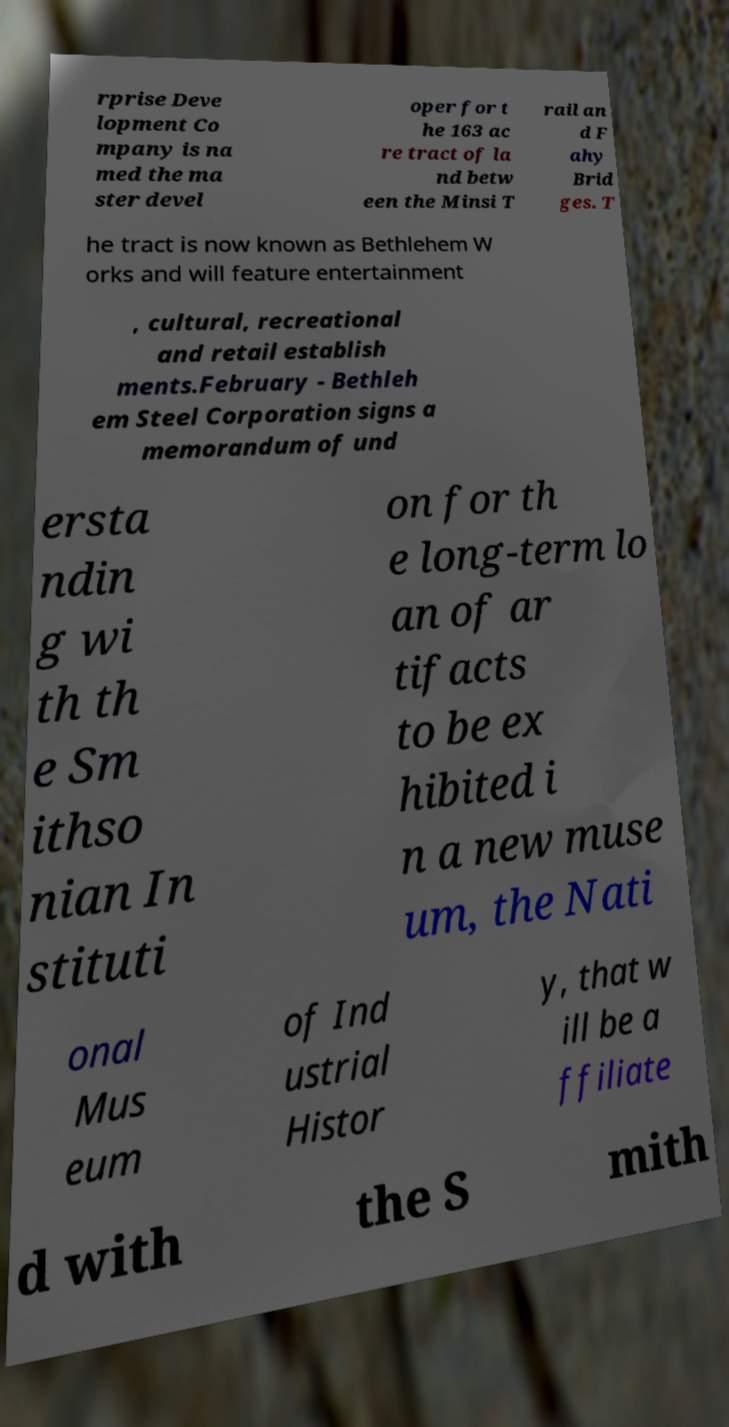For documentation purposes, I need the text within this image transcribed. Could you provide that? rprise Deve lopment Co mpany is na med the ma ster devel oper for t he 163 ac re tract of la nd betw een the Minsi T rail an d F ahy Brid ges. T he tract is now known as Bethlehem W orks and will feature entertainment , cultural, recreational and retail establish ments.February - Bethleh em Steel Corporation signs a memorandum of und ersta ndin g wi th th e Sm ithso nian In stituti on for th e long-term lo an of ar tifacts to be ex hibited i n a new muse um, the Nati onal Mus eum of Ind ustrial Histor y, that w ill be a ffiliate d with the S mith 